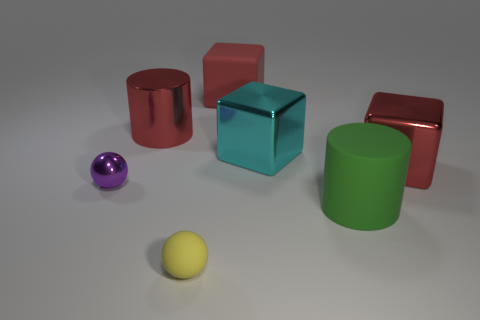Are there an equal number of small metallic objects to the left of the small purple sphere and large green cylinders that are on the right side of the green cylinder?
Give a very brief answer. Yes. What color is the rubber object behind the rubber cylinder?
Offer a terse response. Red. Does the matte cube have the same color as the big block that is in front of the large cyan block?
Keep it short and to the point. Yes. Is the number of yellow balls less than the number of big purple blocks?
Your response must be concise. No. There is a big thing that is in front of the purple shiny object; is its color the same as the rubber ball?
Ensure brevity in your answer.  No. How many other cyan cubes have the same size as the cyan metal block?
Offer a terse response. 0. Are there any big metallic objects that have the same color as the big metallic cylinder?
Your response must be concise. Yes. Is the small yellow sphere made of the same material as the big green thing?
Ensure brevity in your answer.  Yes. What number of purple metallic things are the same shape as the yellow object?
Make the answer very short. 1. There is a tiny purple thing that is made of the same material as the red cylinder; what is its shape?
Your response must be concise. Sphere. 